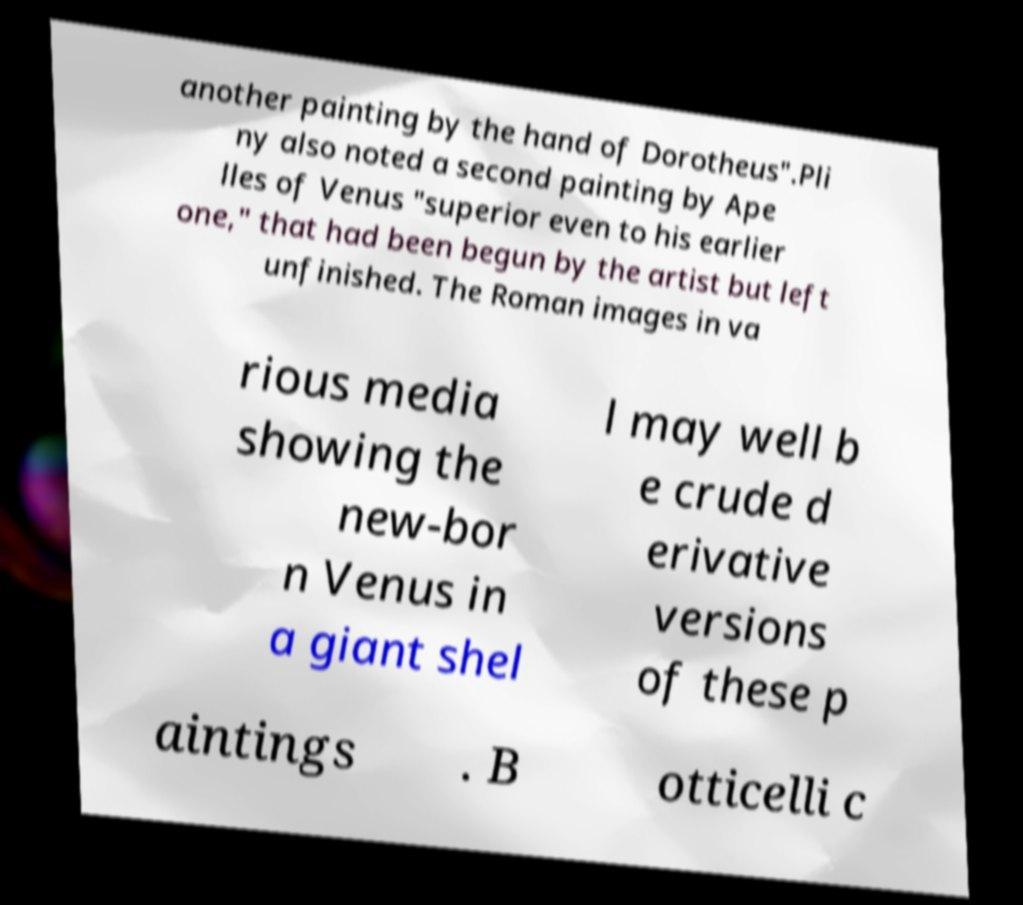There's text embedded in this image that I need extracted. Can you transcribe it verbatim? another painting by the hand of Dorotheus".Pli ny also noted a second painting by Ape lles of Venus "superior even to his earlier one," that had been begun by the artist but left unfinished. The Roman images in va rious media showing the new-bor n Venus in a giant shel l may well b e crude d erivative versions of these p aintings . B otticelli c 